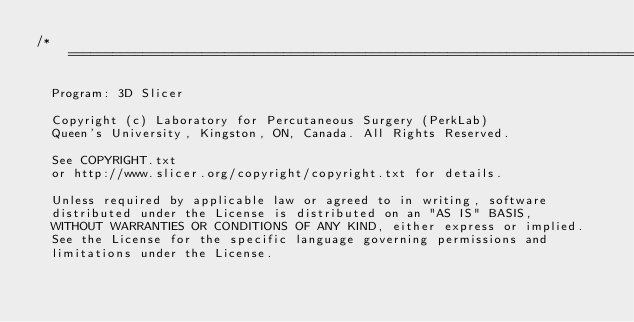Convert code to text. <code><loc_0><loc_0><loc_500><loc_500><_C++_>/*==============================================================================

  Program: 3D Slicer

  Copyright (c) Laboratory for Percutaneous Surgery (PerkLab)
  Queen's University, Kingston, ON, Canada. All Rights Reserved.

  See COPYRIGHT.txt
  or http://www.slicer.org/copyright/copyright.txt for details.

  Unless required by applicable law or agreed to in writing, software
  distributed under the License is distributed on an "AS IS" BASIS,
  WITHOUT WARRANTIES OR CONDITIONS OF ANY KIND, either express or implied.
  See the License for the specific language governing permissions and
  limitations under the License.
</code> 